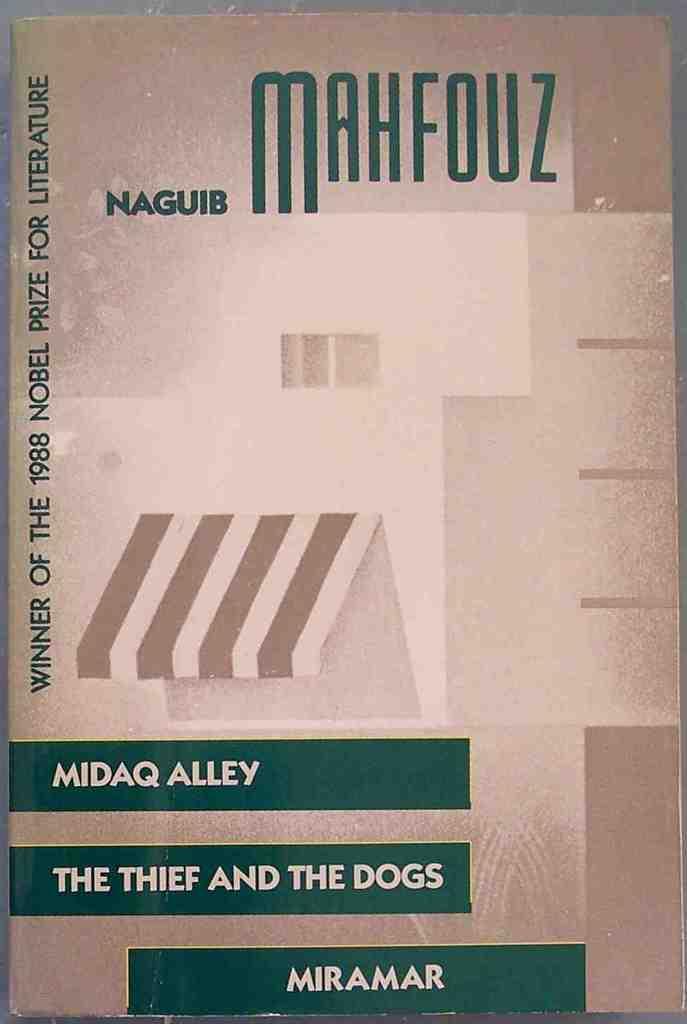What is the thief with?
Offer a terse response. Dogs. Who wrote this?
Offer a very short reply. Naguib mahfouz. 